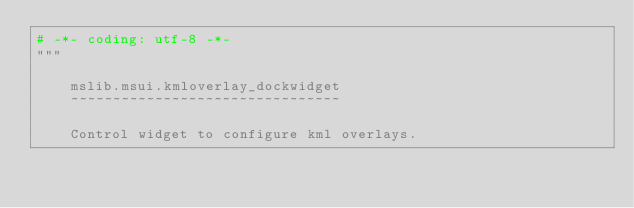Convert code to text. <code><loc_0><loc_0><loc_500><loc_500><_Python_># -*- coding: utf-8 -*-
"""

    mslib.msui.kmloverlay_dockwidget
    ~~~~~~~~~~~~~~~~~~~~~~~~~~~~~~~~

    Control widget to configure kml overlays.
</code> 